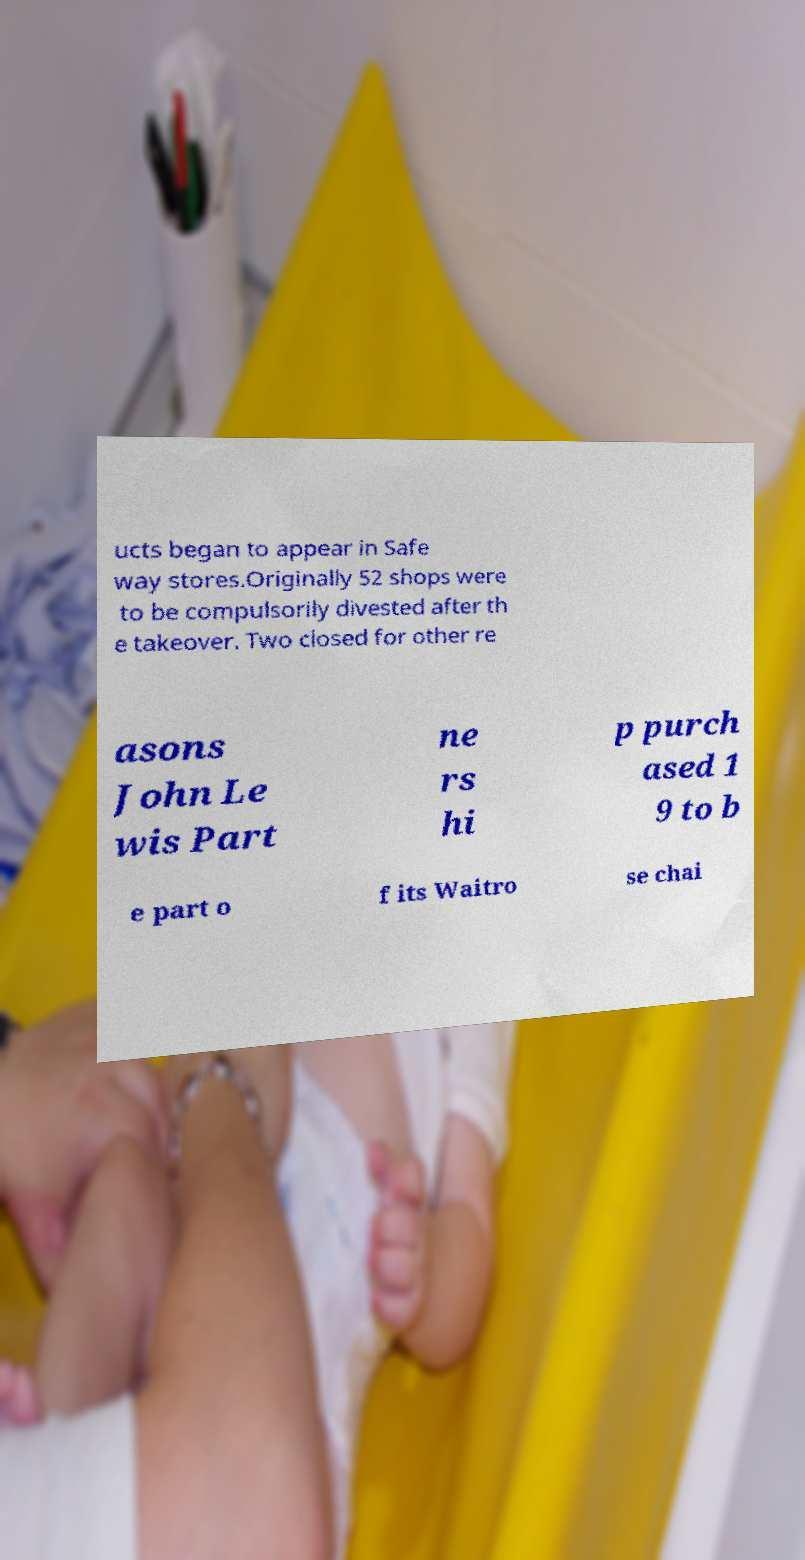What messages or text are displayed in this image? I need them in a readable, typed format. ucts began to appear in Safe way stores.Originally 52 shops were to be compulsorily divested after th e takeover. Two closed for other re asons John Le wis Part ne rs hi p purch ased 1 9 to b e part o f its Waitro se chai 